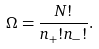<formula> <loc_0><loc_0><loc_500><loc_500>\Omega = \frac { N ! } { n _ { + } ! n _ { - } ! } .</formula> 